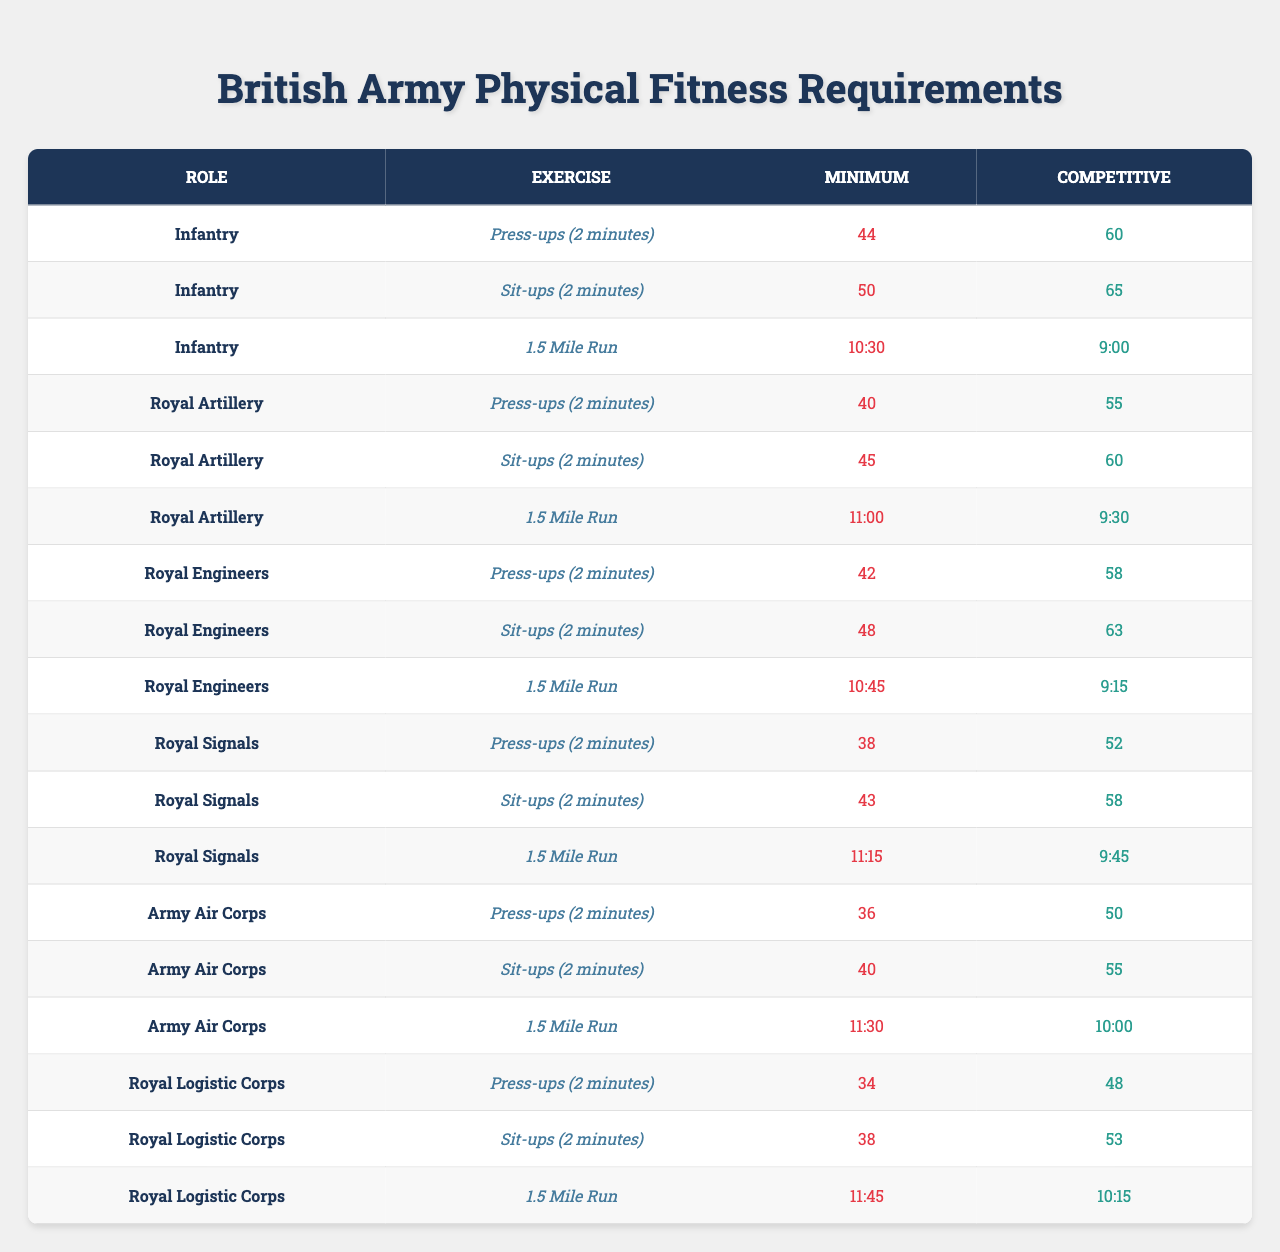What are the minimum press-up requirements for the Infantry role? The table indicates the number of press-ups required in 2 minutes for the Infantry role. It states that the minimum requirement is 44 press-ups.
Answer: 44 What is the competitive sit-up requirement for the Royal Engineers? From the table, the competitive requirement for sit-ups in the Royal Engineers role is listed as 63 sit-ups in 2 minutes.
Answer: 63 Which military role has the lowest minimum requirement for press-ups? By comparing the minimum press-up numbers listed for each role, the Army Air Corps has the lowest requirement with 36 press-ups.
Answer: Army Air Corps What is the difference between the minimum and competitive run times for the Infantry? The minimum run time for the Infantry is 10:30 minutes, and the competitive time is 9:00 minutes. To find the difference, convert both times into seconds: 10:30 is 630 seconds and 9:00 is 540 seconds. The difference is 630 - 540 = 90 seconds, which is 1 minute and 30 seconds.
Answer: 1 minute and 30 seconds Are the competitive requirements for the Royal Signals lower than those for the Royal Logistic Corps in sit-ups? The competitive sit-up requirement for Royal Signals is 58 while for Royal Logistic Corps it is 53. Since 58 is greater than 53, the competitive requirement for Royal Signals is not lower.
Answer: No What is the average minimum press-up requirement across all roles listed in the table? To find the average, sum the minimum press-up requirements: 44 (Infantry) + 40 (Royal Artillery) + 42 (Royal Engineers) + 38 (Royal Signals) + 36 (Army Air Corps) + 34 (Royal Logistic Corps) = 234. There are 6 roles, so the average is 234/6 = 39.
Answer: 39 Which role requires the fastest competitive time for the 1.5-mile run? By inspecting the 1.5-mile run competitive times, the fastest time is 9:00, which belongs to the Infantry role.
Answer: Infantry What is the minimum requirement for sit-ups in the Royal Artillery? The table lists that the minimum requirement for sit-ups in the Royal Artillery role is 45.
Answer: 45 Does the Royal Logistic Corps have a higher competitive press-up requirement than the Army Air Corps? The Royal Logistic Corps has a competitive press-up requirement of 48, while the Army Air Corps has 50. Since 48 is not greater than 50, Royal Logistic Corps does not have a higher requirement.
Answer: No If a candidate can do 50 press-ups in 2 minutes, which military roles do they meet the competitive requirement for? Candidates who can do 50 press-ups meet the competitive requirements for the Royal Artillery (55) and above, Royal Engineers (58), Royal Signals (52) and Army Air Corps (50), but not for the Infantry (60). So they meet the competitive requirement for Royal Signals and Army Air Corps.
Answer: Royal Signals and Army Air Corps 